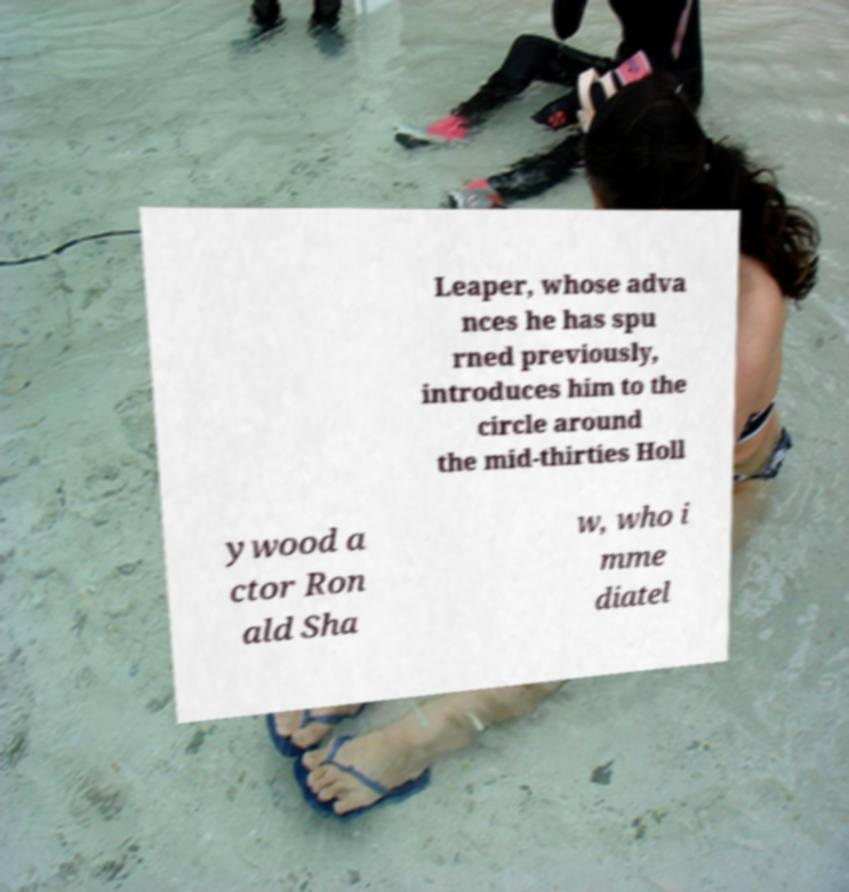Can you read and provide the text displayed in the image?This photo seems to have some interesting text. Can you extract and type it out for me? Leaper, whose adva nces he has spu rned previously, introduces him to the circle around the mid-thirties Holl ywood a ctor Ron ald Sha w, who i mme diatel 